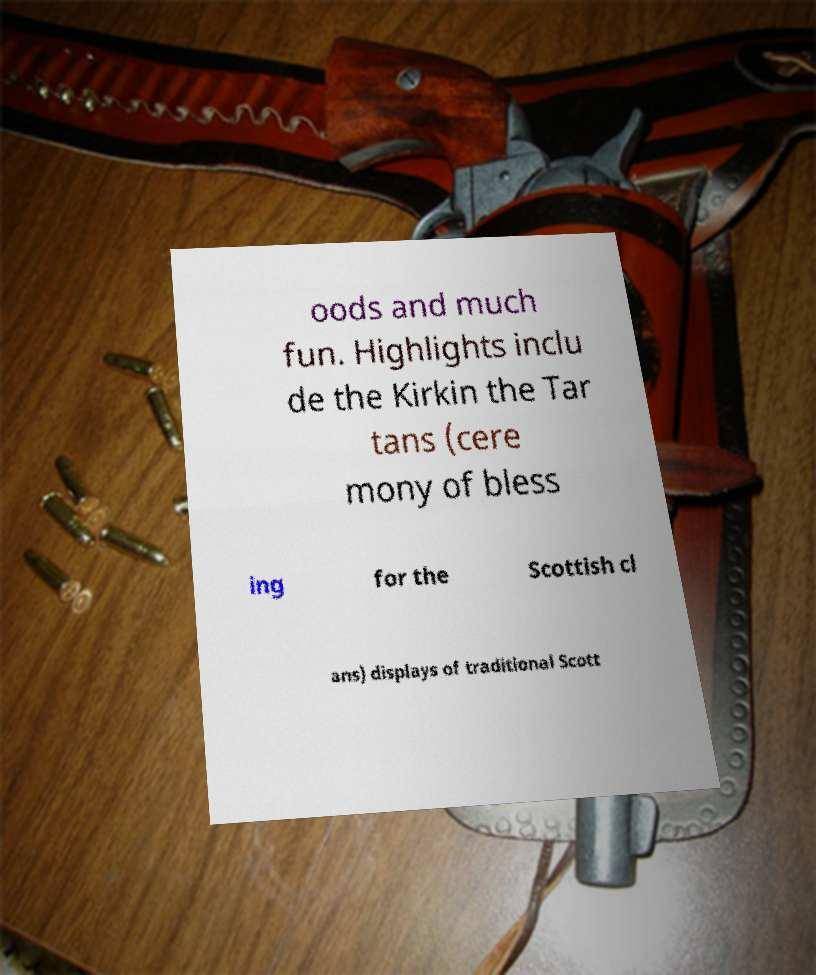Please identify and transcribe the text found in this image. oods and much fun. Highlights inclu de the Kirkin the Tar tans (cere mony of bless ing for the Scottish cl ans) displays of traditional Scott 